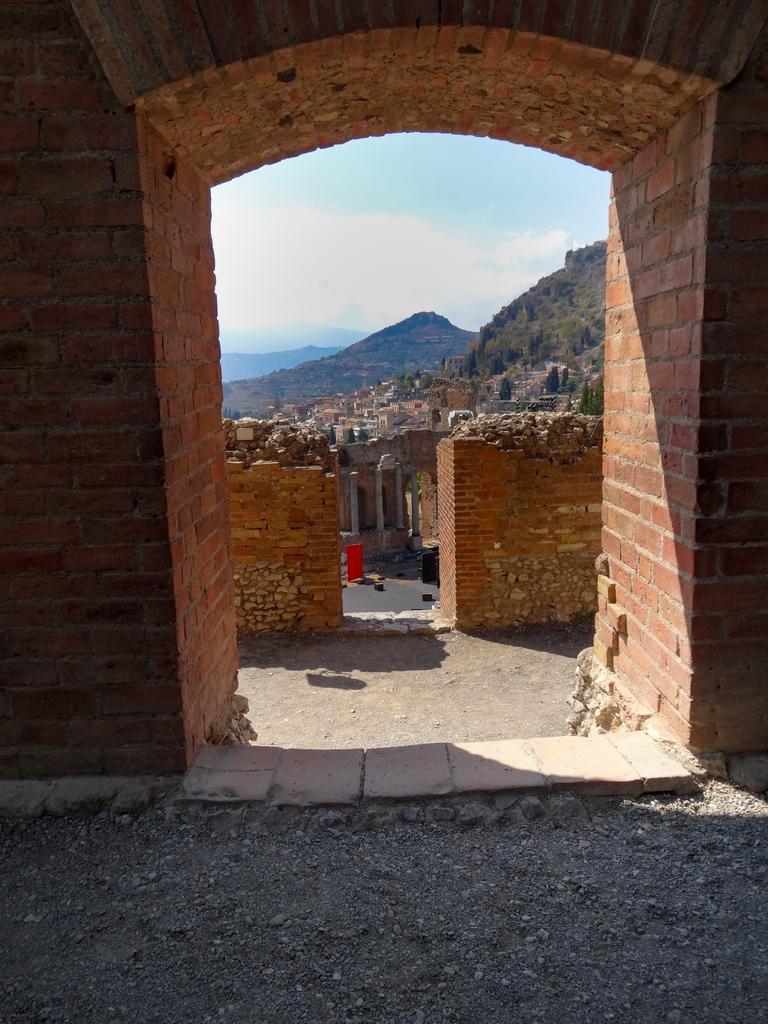How would you summarize this image in a sentence or two? In this image I can see a fort,brick wall,trees and mountains. The sky is in blue and white color. 